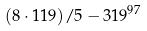Convert formula to latex. <formula><loc_0><loc_0><loc_500><loc_500>( 8 \cdot 1 1 9 ) / 5 - 3 1 9 ^ { 9 7 }</formula> 